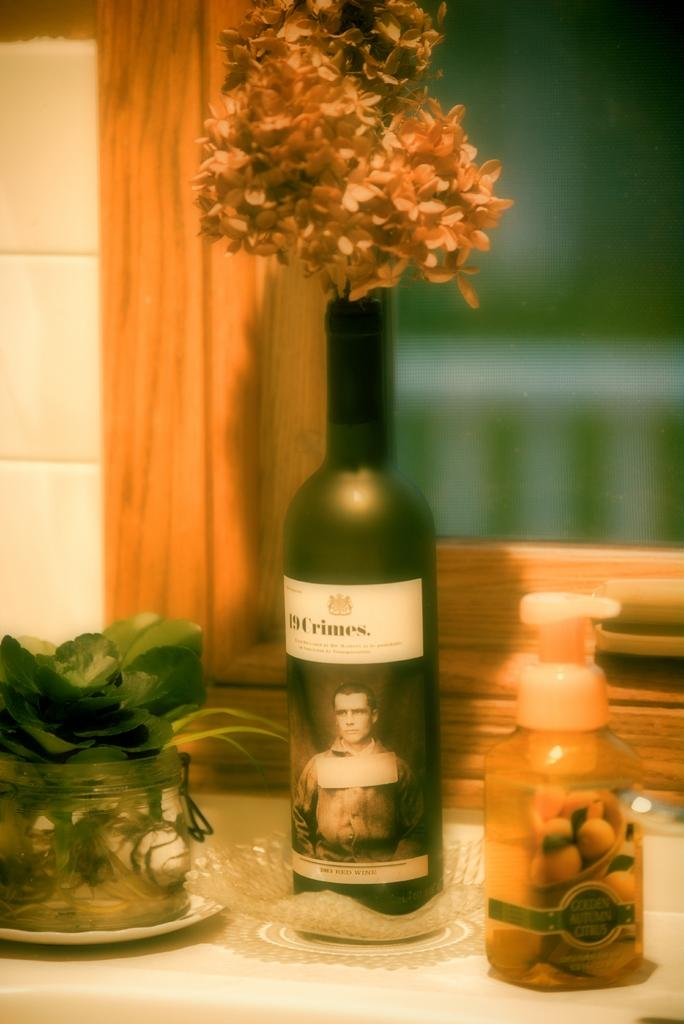What is on the table in the image? There is a wine bottle on the table. What can be seen in a container in the image? There are flowers in a vase. What type of cleaning product is visible in the image? There is a liquid soap bottle. What type of vegetation is in a glass container in the image? There are plants in a glass bowl. How many houses are visible in the image? There are no houses visible in the image. What type of truck is parked next to the plants in the glass bowl? There is no truck present in the image. 